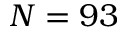<formula> <loc_0><loc_0><loc_500><loc_500>N = 9 3</formula> 